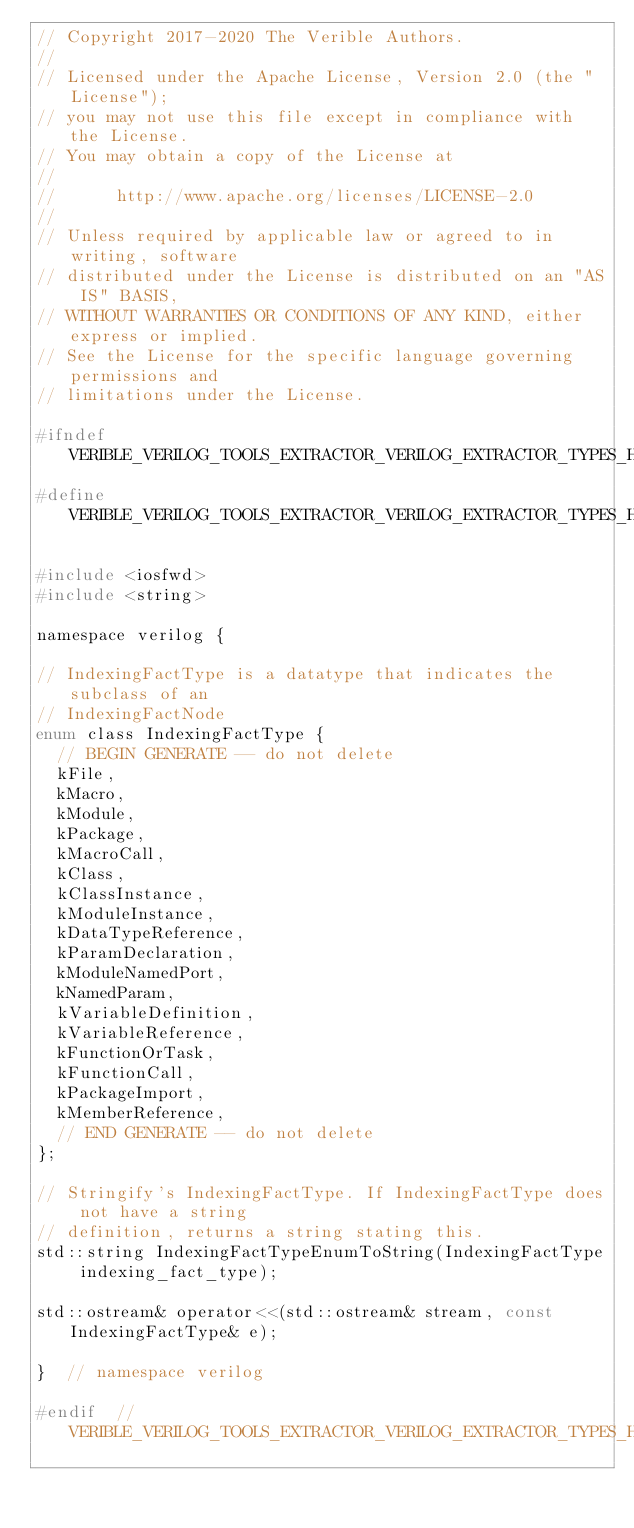<code> <loc_0><loc_0><loc_500><loc_500><_C_>// Copyright 2017-2020 The Verible Authors.
//
// Licensed under the Apache License, Version 2.0 (the "License");
// you may not use this file except in compliance with the License.
// You may obtain a copy of the License at
//
//      http://www.apache.org/licenses/LICENSE-2.0
//
// Unless required by applicable law or agreed to in writing, software
// distributed under the License is distributed on an "AS IS" BASIS,
// WITHOUT WARRANTIES OR CONDITIONS OF ANY KIND, either express or implied.
// See the License for the specific language governing permissions and
// limitations under the License.

#ifndef VERIBLE_VERILOG_TOOLS_EXTRACTOR_VERILOG_EXTRACTOR_TYPES_H
#define VERIBLE_VERILOG_TOOLS_EXTRACTOR_VERILOG_EXTRACTOR_TYPES_H

#include <iosfwd>
#include <string>

namespace verilog {

// IndexingFactType is a datatype that indicates the subclass of an
// IndexingFactNode
enum class IndexingFactType {
  // BEGIN GENERATE -- do not delete
  kFile,
  kMacro,
  kModule,
  kPackage,
  kMacroCall,
  kClass,
  kClassInstance,
  kModuleInstance,
  kDataTypeReference,
  kParamDeclaration,
  kModuleNamedPort,
  kNamedParam,
  kVariableDefinition,
  kVariableReference,
  kFunctionOrTask,
  kFunctionCall,
  kPackageImport,
  kMemberReference,
  // END GENERATE -- do not delete
};

// Stringify's IndexingFactType. If IndexingFactType does not have a string
// definition, returns a string stating this.
std::string IndexingFactTypeEnumToString(IndexingFactType indexing_fact_type);

std::ostream& operator<<(std::ostream& stream, const IndexingFactType& e);

}  // namespace verilog

#endif  // VERIBLE_VERILOG_TOOLS_EXTRACTOR_VERILOG_EXTRACTOR_TYPES_H
</code> 